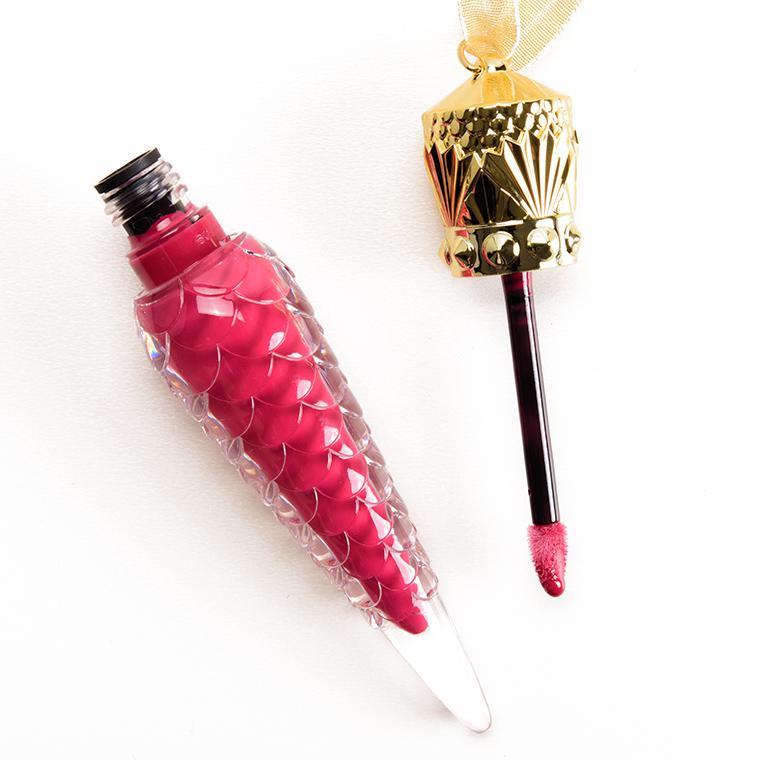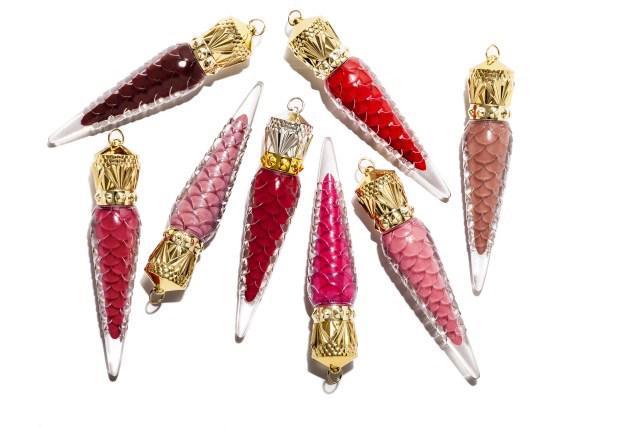The first image is the image on the left, the second image is the image on the right. For the images shown, is this caption "One of the two images shows only one object; an open lip balm, with applicator." true? Answer yes or no. Yes. The first image is the image on the left, the second image is the image on the right. Given the left and right images, does the statement "One vial of cone shaped lip gloss is shown in one of the images while more are shown in the other." hold true? Answer yes or no. Yes. The first image is the image on the left, the second image is the image on the right. Considering the images on both sides, is "An image shows eight different makeup shades in tapered decorative containers, displayed scattered instead of in rows." valid? Answer yes or no. Yes. 